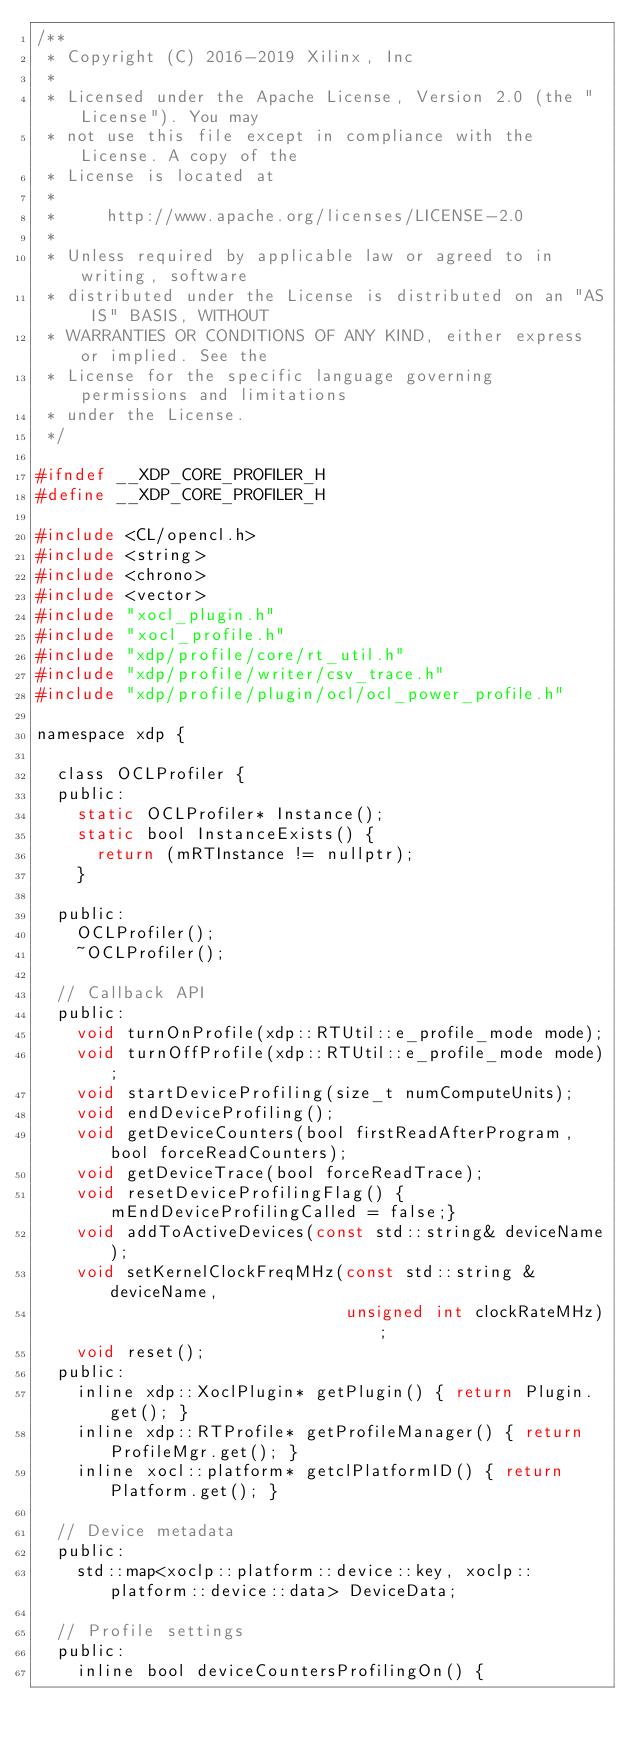<code> <loc_0><loc_0><loc_500><loc_500><_C_>/**
 * Copyright (C) 2016-2019 Xilinx, Inc
 *
 * Licensed under the Apache License, Version 2.0 (the "License"). You may
 * not use this file except in compliance with the License. A copy of the
 * License is located at
 *
 *     http://www.apache.org/licenses/LICENSE-2.0
 *
 * Unless required by applicable law or agreed to in writing, software
 * distributed under the License is distributed on an "AS IS" BASIS, WITHOUT
 * WARRANTIES OR CONDITIONS OF ANY KIND, either express or implied. See the
 * License for the specific language governing permissions and limitations
 * under the License.
 */

#ifndef __XDP_CORE_PROFILER_H
#define __XDP_CORE_PROFILER_H

#include <CL/opencl.h>
#include <string>
#include <chrono>
#include <vector>
#include "xocl_plugin.h"
#include "xocl_profile.h"
#include "xdp/profile/core/rt_util.h"
#include "xdp/profile/writer/csv_trace.h"
#include "xdp/profile/plugin/ocl/ocl_power_profile.h"

namespace xdp {

  class OCLProfiler {
  public:
    static OCLProfiler* Instance();
    static bool InstanceExists() {
      return (mRTInstance != nullptr);
    }

  public:
    OCLProfiler();
    ~OCLProfiler();

  // Callback API
  public:
    void turnOnProfile(xdp::RTUtil::e_profile_mode mode);
    void turnOffProfile(xdp::RTUtil::e_profile_mode mode);
    void startDeviceProfiling(size_t numComputeUnits);
    void endDeviceProfiling();
    void getDeviceCounters(bool firstReadAfterProgram, bool forceReadCounters);
    void getDeviceTrace(bool forceReadTrace);
    void resetDeviceProfilingFlag() {mEndDeviceProfilingCalled = false;}
    void addToActiveDevices(const std::string& deviceName);
    void setKernelClockFreqMHz(const std::string &deviceName,
                               unsigned int clockRateMHz);
    void reset();
  public:
    inline xdp::XoclPlugin* getPlugin() { return Plugin.get(); }
    inline xdp::RTProfile* getProfileManager() { return ProfileMgr.get(); }
    inline xocl::platform* getclPlatformID() { return Platform.get(); }

  // Device metadata
  public:
    std::map<xoclp::platform::device::key, xoclp::platform::device::data> DeviceData;

  // Profile settings
  public:
    inline bool deviceCountersProfilingOn() {</code> 